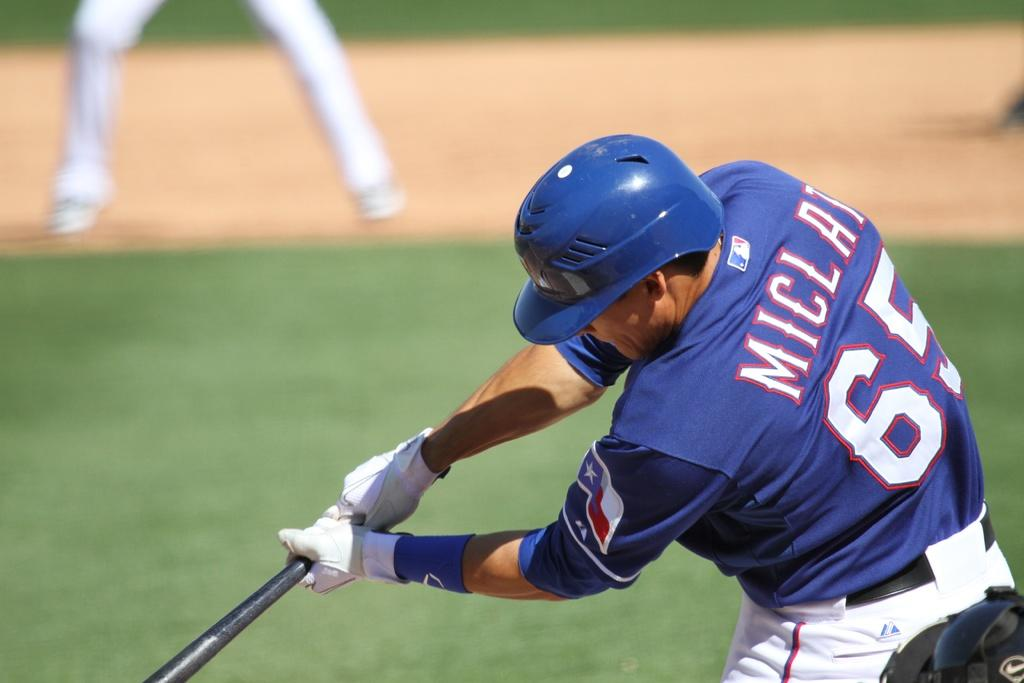What is the man in the image holding? The man is holding a baseball bat. What is the man wearing on his head? The man is wearing a helmet. What is the man wearing on his hand? The man is wearing a glove. What is the man wearing on his wrist? The man is wearing a hand band. What is the man wearing on his upper body? The man is wearing a T-shirt. What is the man wearing on his lower body? The man is wearing trousers. What can be seen in the background of the image? The background appears to be grass, and there are legs visible. How many sheep can be seen in the image? There are no sheep present in the image. What type of heart is visible in the image? There is no heart visible in the image. 